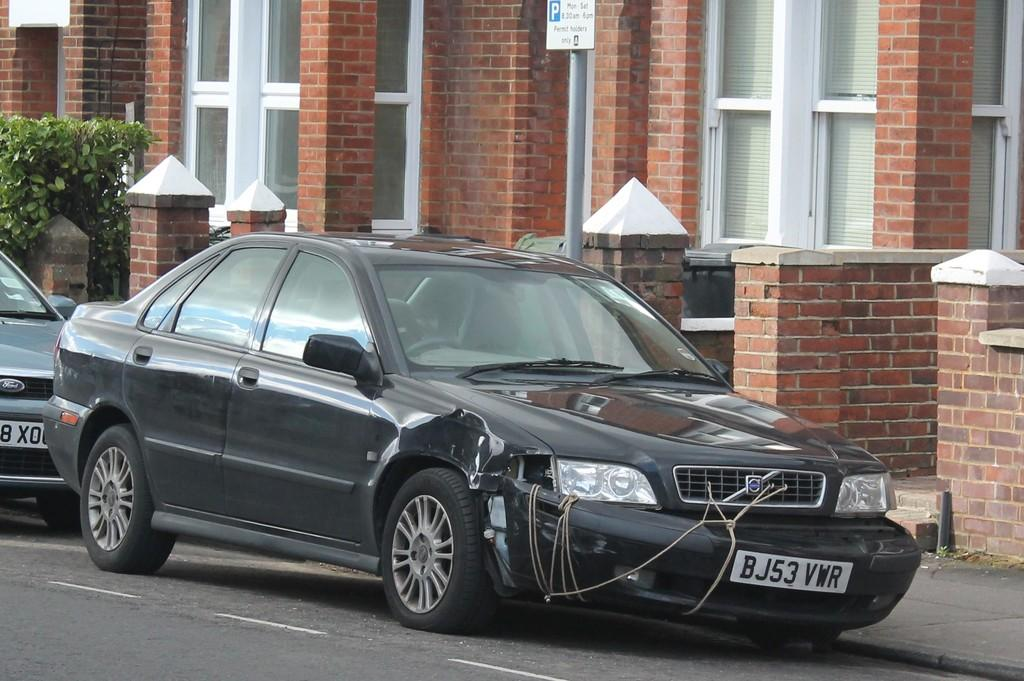What type of vehicles can be seen on the road in the image? There are cars on the road in the image. What other elements can be seen in the image besides the cars? There are plants, a board, a building, and glasses in the image. What type of cord is being used to hold the potato in the image? There is no potato or cord present in the image. How many nails can be seen in the image? There are no nails visible in the image. 